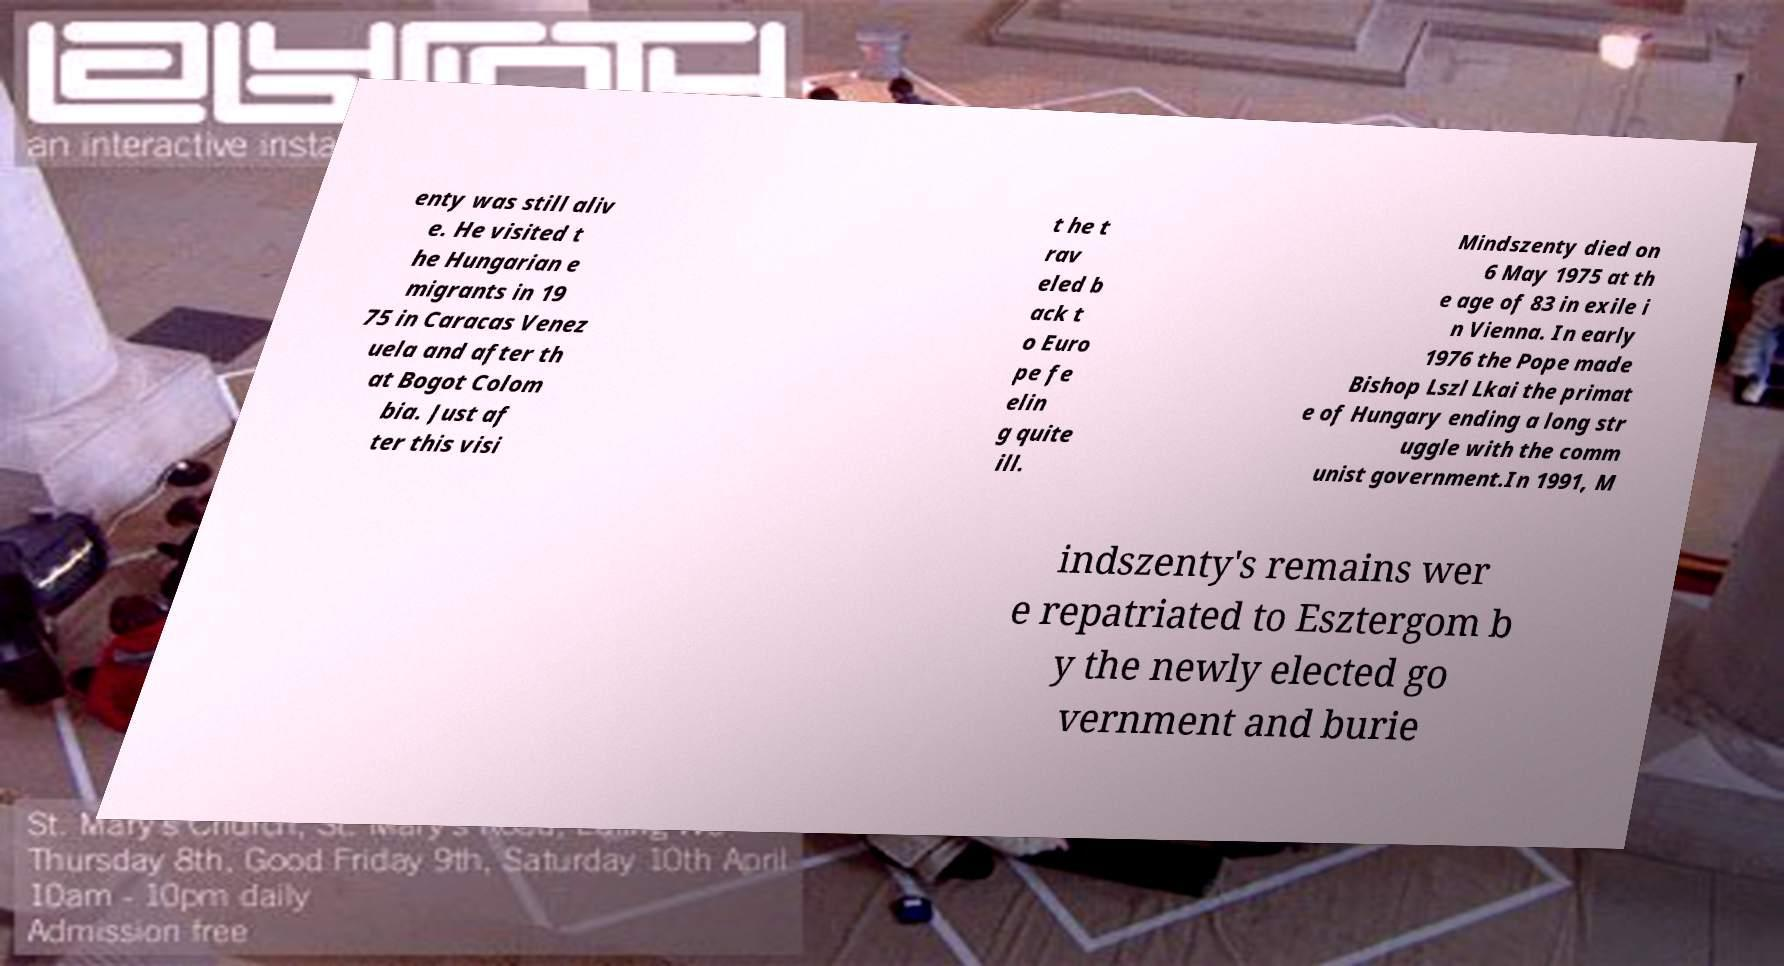Please identify and transcribe the text found in this image. enty was still aliv e. He visited t he Hungarian e migrants in 19 75 in Caracas Venez uela and after th at Bogot Colom bia. Just af ter this visi t he t rav eled b ack t o Euro pe fe elin g quite ill. Mindszenty died on 6 May 1975 at th e age of 83 in exile i n Vienna. In early 1976 the Pope made Bishop Lszl Lkai the primat e of Hungary ending a long str uggle with the comm unist government.In 1991, M indszenty's remains wer e repatriated to Esztergom b y the newly elected go vernment and burie 